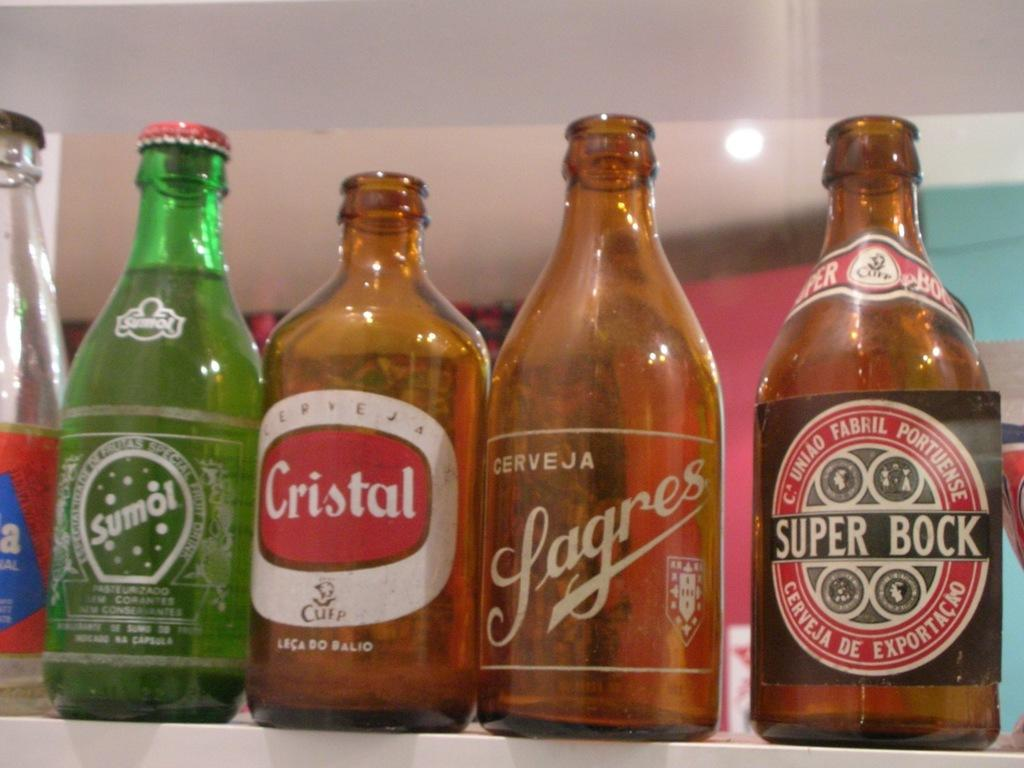Provide a one-sentence caption for the provided image. Four bottles, the one of the far left being labelled Super Bock. 